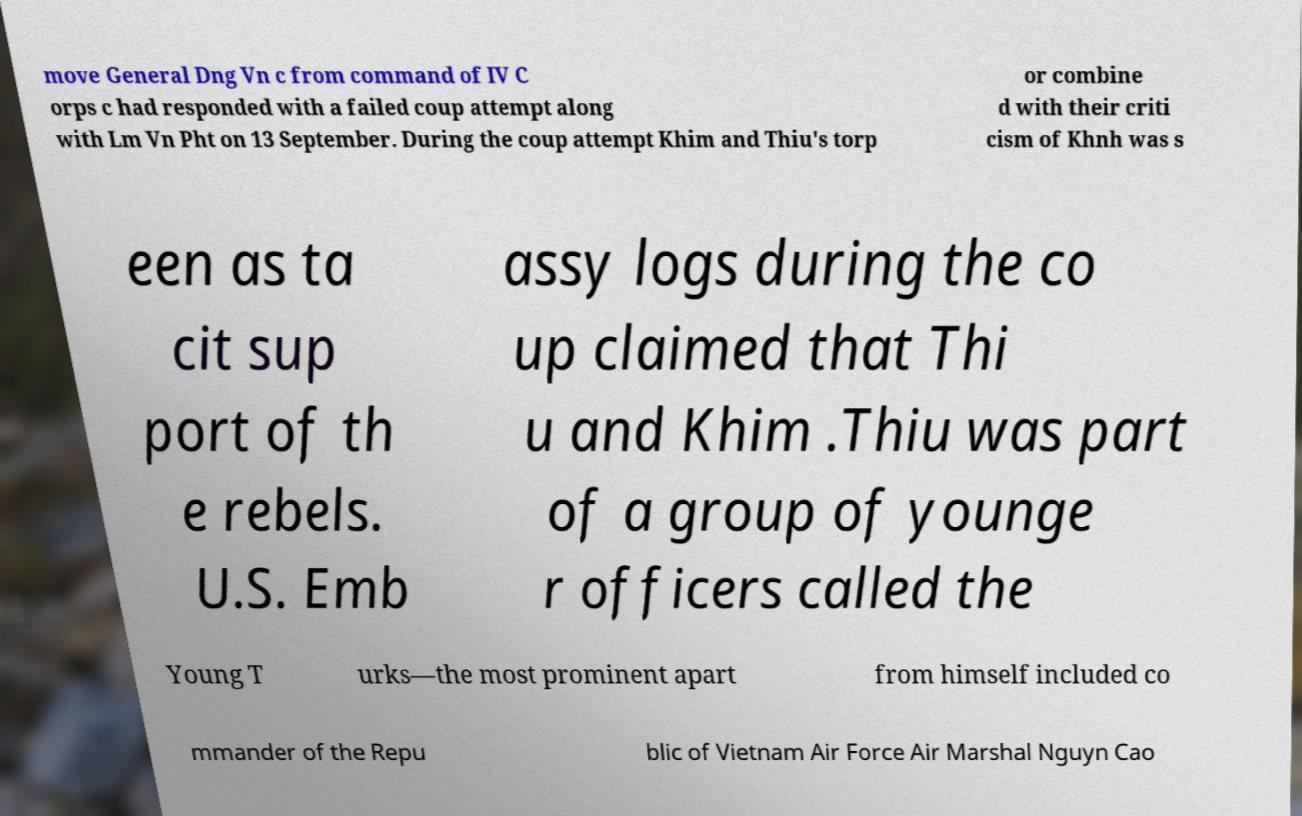For documentation purposes, I need the text within this image transcribed. Could you provide that? move General Dng Vn c from command of IV C orps c had responded with a failed coup attempt along with Lm Vn Pht on 13 September. During the coup attempt Khim and Thiu's torp or combine d with their criti cism of Khnh was s een as ta cit sup port of th e rebels. U.S. Emb assy logs during the co up claimed that Thi u and Khim .Thiu was part of a group of younge r officers called the Young T urks—the most prominent apart from himself included co mmander of the Repu blic of Vietnam Air Force Air Marshal Nguyn Cao 